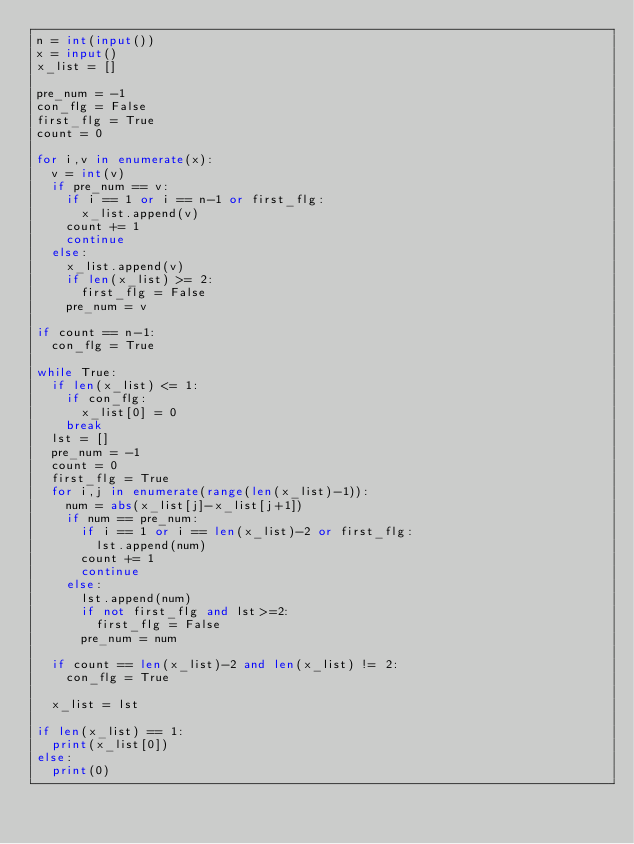Convert code to text. <code><loc_0><loc_0><loc_500><loc_500><_Python_>n = int(input())
x = input()
x_list = []

pre_num = -1
con_flg = False
first_flg = True
count = 0

for i,v in enumerate(x):
  v = int(v)
  if pre_num == v:
    if i == 1 or i == n-1 or first_flg:
    	x_list.append(v)
    count += 1
    continue
  else:
    x_list.append(v)
    if len(x_list) >= 2:
      first_flg = False
    pre_num = v

if count == n-1:
  con_flg = True
  
while True:
  if len(x_list) <= 1:
    if con_flg:
      x_list[0] = 0
    break
  lst = []
  pre_num = -1
  count = 0
  first_flg = True
  for i,j in enumerate(range(len(x_list)-1)):
    num = abs(x_list[j]-x_list[j+1])
    if num == pre_num:
      if i == 1 or i == len(x_list)-2 or first_flg:
        lst.append(num)
      count += 1
      continue
    else:
      lst.append(num)
      if not first_flg and lst>=2:
        first_flg = False
      pre_num = num
      
  if count == len(x_list)-2 and len(x_list) != 2:
    con_flg = True
    
  x_list = lst
  
if len(x_list) == 1:
  print(x_list[0])
else:
  print(0)</code> 